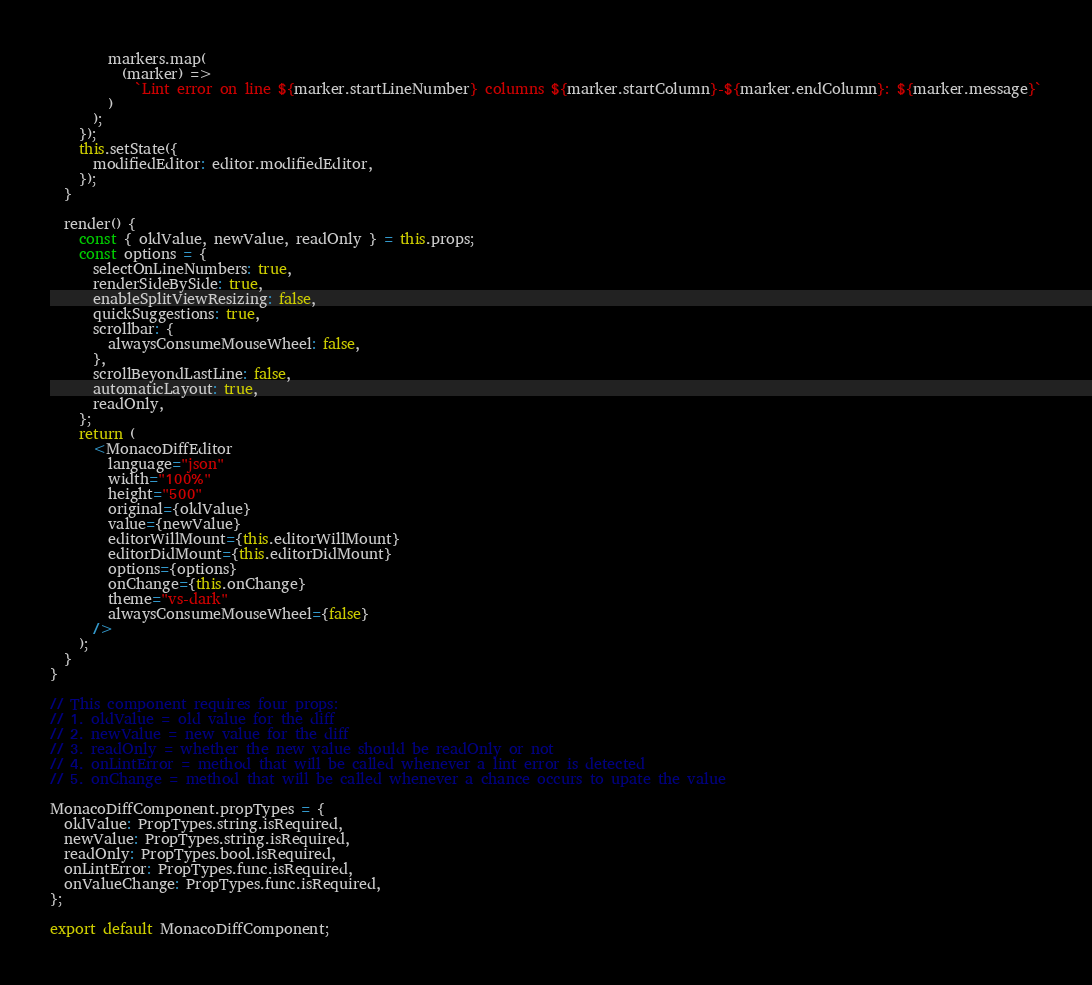<code> <loc_0><loc_0><loc_500><loc_500><_JavaScript_>        markers.map(
          (marker) =>
            `Lint error on line ${marker.startLineNumber} columns ${marker.startColumn}-${marker.endColumn}: ${marker.message}`
        )
      );
    });
    this.setState({
      modifiedEditor: editor.modifiedEditor,
    });
  }

  render() {
    const { oldValue, newValue, readOnly } = this.props;
    const options = {
      selectOnLineNumbers: true,
      renderSideBySide: true,
      enableSplitViewResizing: false,
      quickSuggestions: true,
      scrollbar: {
        alwaysConsumeMouseWheel: false,
      },
      scrollBeyondLastLine: false,
      automaticLayout: true,
      readOnly,
    };
    return (
      <MonacoDiffEditor
        language="json"
        width="100%"
        height="500"
        original={oldValue}
        value={newValue}
        editorWillMount={this.editorWillMount}
        editorDidMount={this.editorDidMount}
        options={options}
        onChange={this.onChange}
        theme="vs-dark"
        alwaysConsumeMouseWheel={false}
      />
    );
  }
}

// This component requires four props:
// 1. oldValue = old value for the diff
// 2. newValue = new value for the diff
// 3. readOnly = whether the new value should be readOnly or not
// 4. onLintError = method that will be called whenever a lint error is detected
// 5. onChange = method that will be called whenever a chance occurs to upate the value

MonacoDiffComponent.propTypes = {
  oldValue: PropTypes.string.isRequired,
  newValue: PropTypes.string.isRequired,
  readOnly: PropTypes.bool.isRequired,
  onLintError: PropTypes.func.isRequired,
  onValueChange: PropTypes.func.isRequired,
};

export default MonacoDiffComponent;
</code> 